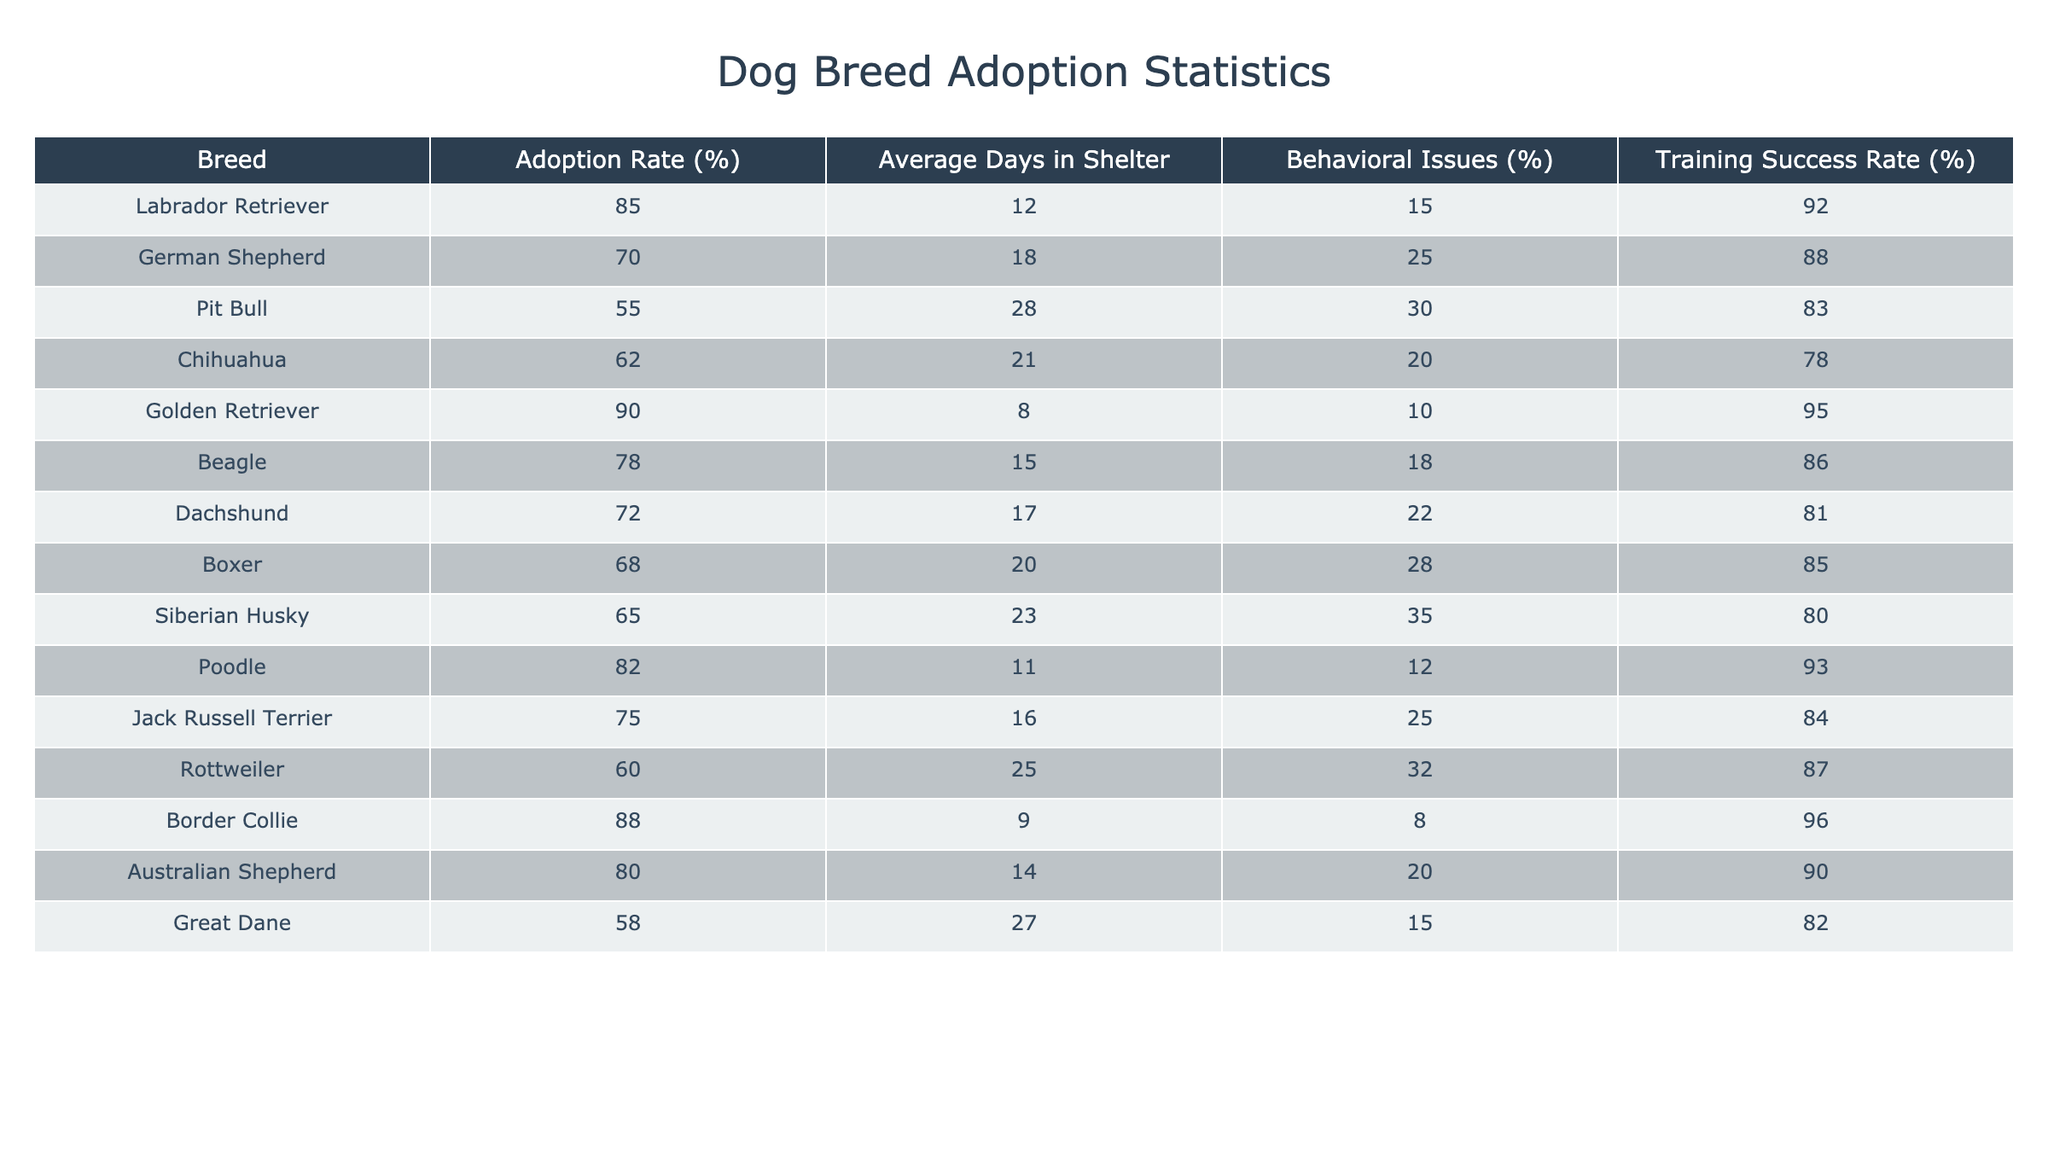What is the adoption rate for Golden Retrievers? The table shows the adoption rate for Golden Retrievers as 90%.
Answer: 90% Which dog breed has the highest average days in shelter? The breed with the highest average days in shelter, which is 28 days, is the Pit Bull.
Answer: Pit Bull What is the average adoption rate for breeds with less than 20% behavioral issues? The breeds with less than 20% behavioral issues are Labrador Retriever (15%), Golden Retriever (10%), Beagle (18%), Poodle (12%), and Border Collie (8%). Their adoption rates are 85%, 90%, 78%, 82%, and 88% respectively. Summing these gives a total of 85 + 90 + 78 + 82 + 88 = 423. There are 5 breeds, so the average is 423 / 5 = 84.6%.
Answer: 84.6% Is it true that Chihuahuas have a higher training success rate than Rottweilers? In the table, Chihuahuas have a training success rate of 78% while Rottweilers have a success rate of 87%. Thus, the statement is false.
Answer: No What is the difference in adoption rates between the Labrador Retriever and the Great Dane? The adoption rate for the Labrador Retriever is 85% and for the Great Dane it is 58%. The difference is 85 - 58 = 27%.
Answer: 27% Which breed has the lowest percentage of behavioral issues? The breed with the lowest percentage of behavioral issues is the Border Collie at 8%.
Answer: Border Collie What is the average training success rate for all the dog breeds listed? To find the average training success rate, we sum the training success rates: 92 + 88 + 83 + 78 + 95 + 86 + 81 + 85 + 80 + 93 + 84 + 87 + 96 + 90 + 82 = 1304. There are 15 breeds, so the average is 1304 / 15 = 86.93%.
Answer: 86.93% Which dog breeds have a higher adoption rate than the average of 75%? The breeds with an adoption rate higher than 75% are Labrador Retriever (85%), Golden Retriever (90%), Beagle (78%), Poodle (82%), and Border Collie (88%).
Answer: Labrador Retriever, Golden Retriever, Beagle, Poodle, Border Collie 